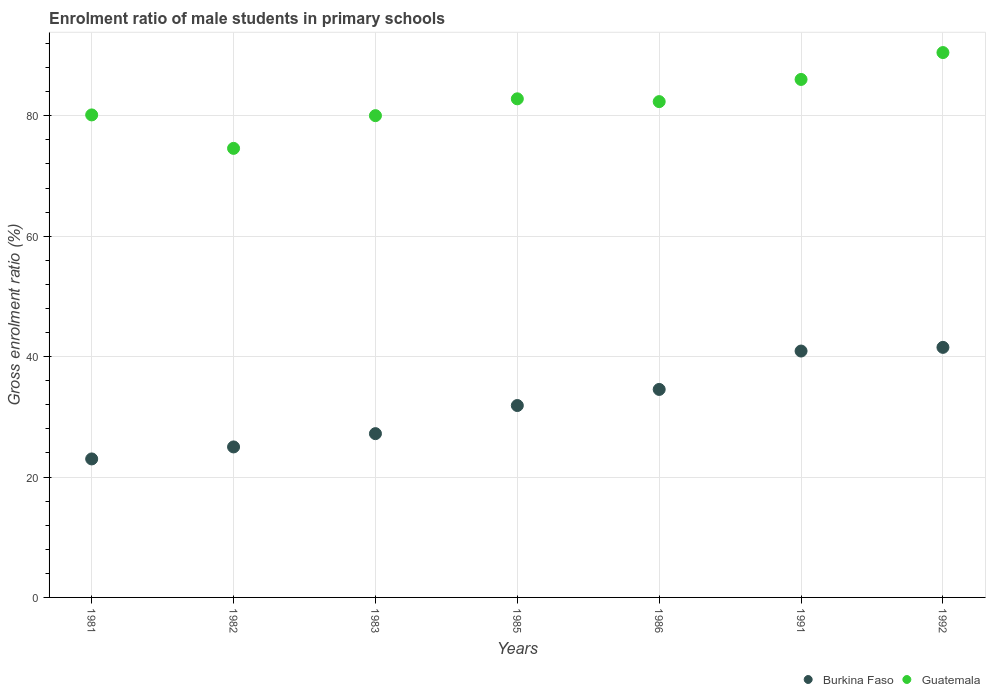How many different coloured dotlines are there?
Make the answer very short. 2. Is the number of dotlines equal to the number of legend labels?
Your answer should be compact. Yes. What is the enrolment ratio of male students in primary schools in Guatemala in 1991?
Offer a very short reply. 86.04. Across all years, what is the maximum enrolment ratio of male students in primary schools in Guatemala?
Give a very brief answer. 90.5. Across all years, what is the minimum enrolment ratio of male students in primary schools in Burkina Faso?
Offer a terse response. 23. What is the total enrolment ratio of male students in primary schools in Burkina Faso in the graph?
Make the answer very short. 224.08. What is the difference between the enrolment ratio of male students in primary schools in Burkina Faso in 1985 and that in 1986?
Keep it short and to the point. -2.67. What is the difference between the enrolment ratio of male students in primary schools in Burkina Faso in 1985 and the enrolment ratio of male students in primary schools in Guatemala in 1981?
Keep it short and to the point. -48.27. What is the average enrolment ratio of male students in primary schools in Guatemala per year?
Give a very brief answer. 82.35. In the year 1992, what is the difference between the enrolment ratio of male students in primary schools in Burkina Faso and enrolment ratio of male students in primary schools in Guatemala?
Your answer should be very brief. -48.96. In how many years, is the enrolment ratio of male students in primary schools in Burkina Faso greater than 20 %?
Offer a very short reply. 7. What is the ratio of the enrolment ratio of male students in primary schools in Burkina Faso in 1985 to that in 1986?
Provide a short and direct response. 0.92. Is the enrolment ratio of male students in primary schools in Guatemala in 1981 less than that in 1985?
Your answer should be compact. Yes. Is the difference between the enrolment ratio of male students in primary schools in Burkina Faso in 1982 and 1985 greater than the difference between the enrolment ratio of male students in primary schools in Guatemala in 1982 and 1985?
Offer a very short reply. Yes. What is the difference between the highest and the second highest enrolment ratio of male students in primary schools in Guatemala?
Your answer should be compact. 4.46. What is the difference between the highest and the lowest enrolment ratio of male students in primary schools in Guatemala?
Your response must be concise. 15.91. Is the enrolment ratio of male students in primary schools in Burkina Faso strictly greater than the enrolment ratio of male students in primary schools in Guatemala over the years?
Offer a terse response. No. Is the enrolment ratio of male students in primary schools in Guatemala strictly less than the enrolment ratio of male students in primary schools in Burkina Faso over the years?
Make the answer very short. No. What is the difference between two consecutive major ticks on the Y-axis?
Provide a succinct answer. 20. Are the values on the major ticks of Y-axis written in scientific E-notation?
Your answer should be compact. No. Does the graph contain any zero values?
Offer a terse response. No. Does the graph contain grids?
Provide a short and direct response. Yes. Where does the legend appear in the graph?
Ensure brevity in your answer.  Bottom right. What is the title of the graph?
Ensure brevity in your answer.  Enrolment ratio of male students in primary schools. What is the Gross enrolment ratio (%) of Burkina Faso in 1981?
Give a very brief answer. 23. What is the Gross enrolment ratio (%) of Guatemala in 1981?
Provide a succinct answer. 80.14. What is the Gross enrolment ratio (%) in Burkina Faso in 1982?
Ensure brevity in your answer.  25. What is the Gross enrolment ratio (%) in Guatemala in 1982?
Your response must be concise. 74.59. What is the Gross enrolment ratio (%) of Burkina Faso in 1983?
Offer a very short reply. 27.2. What is the Gross enrolment ratio (%) in Guatemala in 1983?
Your answer should be compact. 80.02. What is the Gross enrolment ratio (%) of Burkina Faso in 1985?
Make the answer very short. 31.87. What is the Gross enrolment ratio (%) of Guatemala in 1985?
Offer a terse response. 82.82. What is the Gross enrolment ratio (%) of Burkina Faso in 1986?
Provide a succinct answer. 34.55. What is the Gross enrolment ratio (%) of Guatemala in 1986?
Offer a terse response. 82.35. What is the Gross enrolment ratio (%) in Burkina Faso in 1991?
Your answer should be very brief. 40.92. What is the Gross enrolment ratio (%) in Guatemala in 1991?
Offer a terse response. 86.04. What is the Gross enrolment ratio (%) of Burkina Faso in 1992?
Keep it short and to the point. 41.53. What is the Gross enrolment ratio (%) of Guatemala in 1992?
Your response must be concise. 90.5. Across all years, what is the maximum Gross enrolment ratio (%) in Burkina Faso?
Offer a terse response. 41.53. Across all years, what is the maximum Gross enrolment ratio (%) of Guatemala?
Provide a succinct answer. 90.5. Across all years, what is the minimum Gross enrolment ratio (%) in Burkina Faso?
Your answer should be very brief. 23. Across all years, what is the minimum Gross enrolment ratio (%) of Guatemala?
Offer a terse response. 74.59. What is the total Gross enrolment ratio (%) of Burkina Faso in the graph?
Your response must be concise. 224.08. What is the total Gross enrolment ratio (%) in Guatemala in the graph?
Keep it short and to the point. 576.45. What is the difference between the Gross enrolment ratio (%) of Burkina Faso in 1981 and that in 1982?
Offer a terse response. -1.99. What is the difference between the Gross enrolment ratio (%) in Guatemala in 1981 and that in 1982?
Provide a short and direct response. 5.56. What is the difference between the Gross enrolment ratio (%) in Burkina Faso in 1981 and that in 1983?
Make the answer very short. -4.2. What is the difference between the Gross enrolment ratio (%) of Guatemala in 1981 and that in 1983?
Make the answer very short. 0.12. What is the difference between the Gross enrolment ratio (%) in Burkina Faso in 1981 and that in 1985?
Ensure brevity in your answer.  -8.87. What is the difference between the Gross enrolment ratio (%) in Guatemala in 1981 and that in 1985?
Offer a terse response. -2.67. What is the difference between the Gross enrolment ratio (%) of Burkina Faso in 1981 and that in 1986?
Give a very brief answer. -11.54. What is the difference between the Gross enrolment ratio (%) in Guatemala in 1981 and that in 1986?
Offer a very short reply. -2.21. What is the difference between the Gross enrolment ratio (%) in Burkina Faso in 1981 and that in 1991?
Offer a terse response. -17.92. What is the difference between the Gross enrolment ratio (%) of Guatemala in 1981 and that in 1991?
Your answer should be compact. -5.89. What is the difference between the Gross enrolment ratio (%) of Burkina Faso in 1981 and that in 1992?
Your answer should be very brief. -18.53. What is the difference between the Gross enrolment ratio (%) of Guatemala in 1981 and that in 1992?
Make the answer very short. -10.36. What is the difference between the Gross enrolment ratio (%) in Burkina Faso in 1982 and that in 1983?
Offer a very short reply. -2.21. What is the difference between the Gross enrolment ratio (%) of Guatemala in 1982 and that in 1983?
Offer a terse response. -5.43. What is the difference between the Gross enrolment ratio (%) in Burkina Faso in 1982 and that in 1985?
Offer a very short reply. -6.88. What is the difference between the Gross enrolment ratio (%) of Guatemala in 1982 and that in 1985?
Your response must be concise. -8.23. What is the difference between the Gross enrolment ratio (%) in Burkina Faso in 1982 and that in 1986?
Your answer should be very brief. -9.55. What is the difference between the Gross enrolment ratio (%) of Guatemala in 1982 and that in 1986?
Your answer should be compact. -7.77. What is the difference between the Gross enrolment ratio (%) in Burkina Faso in 1982 and that in 1991?
Your answer should be compact. -15.93. What is the difference between the Gross enrolment ratio (%) of Guatemala in 1982 and that in 1991?
Keep it short and to the point. -11.45. What is the difference between the Gross enrolment ratio (%) of Burkina Faso in 1982 and that in 1992?
Offer a very short reply. -16.54. What is the difference between the Gross enrolment ratio (%) in Guatemala in 1982 and that in 1992?
Your response must be concise. -15.91. What is the difference between the Gross enrolment ratio (%) of Burkina Faso in 1983 and that in 1985?
Offer a terse response. -4.67. What is the difference between the Gross enrolment ratio (%) in Guatemala in 1983 and that in 1985?
Your response must be concise. -2.8. What is the difference between the Gross enrolment ratio (%) of Burkina Faso in 1983 and that in 1986?
Provide a succinct answer. -7.34. What is the difference between the Gross enrolment ratio (%) in Guatemala in 1983 and that in 1986?
Your answer should be very brief. -2.33. What is the difference between the Gross enrolment ratio (%) of Burkina Faso in 1983 and that in 1991?
Give a very brief answer. -13.72. What is the difference between the Gross enrolment ratio (%) of Guatemala in 1983 and that in 1991?
Give a very brief answer. -6.01. What is the difference between the Gross enrolment ratio (%) in Burkina Faso in 1983 and that in 1992?
Provide a short and direct response. -14.33. What is the difference between the Gross enrolment ratio (%) of Guatemala in 1983 and that in 1992?
Your answer should be very brief. -10.48. What is the difference between the Gross enrolment ratio (%) of Burkina Faso in 1985 and that in 1986?
Offer a very short reply. -2.67. What is the difference between the Gross enrolment ratio (%) of Guatemala in 1985 and that in 1986?
Ensure brevity in your answer.  0.46. What is the difference between the Gross enrolment ratio (%) of Burkina Faso in 1985 and that in 1991?
Give a very brief answer. -9.05. What is the difference between the Gross enrolment ratio (%) in Guatemala in 1985 and that in 1991?
Your response must be concise. -3.22. What is the difference between the Gross enrolment ratio (%) in Burkina Faso in 1985 and that in 1992?
Your response must be concise. -9.66. What is the difference between the Gross enrolment ratio (%) of Guatemala in 1985 and that in 1992?
Provide a short and direct response. -7.68. What is the difference between the Gross enrolment ratio (%) in Burkina Faso in 1986 and that in 1991?
Make the answer very short. -6.38. What is the difference between the Gross enrolment ratio (%) of Guatemala in 1986 and that in 1991?
Offer a very short reply. -3.68. What is the difference between the Gross enrolment ratio (%) in Burkina Faso in 1986 and that in 1992?
Ensure brevity in your answer.  -6.99. What is the difference between the Gross enrolment ratio (%) in Guatemala in 1986 and that in 1992?
Keep it short and to the point. -8.15. What is the difference between the Gross enrolment ratio (%) in Burkina Faso in 1991 and that in 1992?
Your answer should be compact. -0.61. What is the difference between the Gross enrolment ratio (%) in Guatemala in 1991 and that in 1992?
Provide a short and direct response. -4.46. What is the difference between the Gross enrolment ratio (%) in Burkina Faso in 1981 and the Gross enrolment ratio (%) in Guatemala in 1982?
Offer a very short reply. -51.58. What is the difference between the Gross enrolment ratio (%) of Burkina Faso in 1981 and the Gross enrolment ratio (%) of Guatemala in 1983?
Provide a short and direct response. -57.02. What is the difference between the Gross enrolment ratio (%) of Burkina Faso in 1981 and the Gross enrolment ratio (%) of Guatemala in 1985?
Your answer should be compact. -59.81. What is the difference between the Gross enrolment ratio (%) in Burkina Faso in 1981 and the Gross enrolment ratio (%) in Guatemala in 1986?
Your answer should be very brief. -59.35. What is the difference between the Gross enrolment ratio (%) in Burkina Faso in 1981 and the Gross enrolment ratio (%) in Guatemala in 1991?
Your answer should be compact. -63.03. What is the difference between the Gross enrolment ratio (%) of Burkina Faso in 1981 and the Gross enrolment ratio (%) of Guatemala in 1992?
Your answer should be compact. -67.5. What is the difference between the Gross enrolment ratio (%) of Burkina Faso in 1982 and the Gross enrolment ratio (%) of Guatemala in 1983?
Provide a short and direct response. -55.02. What is the difference between the Gross enrolment ratio (%) of Burkina Faso in 1982 and the Gross enrolment ratio (%) of Guatemala in 1985?
Keep it short and to the point. -57.82. What is the difference between the Gross enrolment ratio (%) of Burkina Faso in 1982 and the Gross enrolment ratio (%) of Guatemala in 1986?
Make the answer very short. -57.35. What is the difference between the Gross enrolment ratio (%) of Burkina Faso in 1982 and the Gross enrolment ratio (%) of Guatemala in 1991?
Your response must be concise. -61.04. What is the difference between the Gross enrolment ratio (%) in Burkina Faso in 1982 and the Gross enrolment ratio (%) in Guatemala in 1992?
Your answer should be very brief. -65.5. What is the difference between the Gross enrolment ratio (%) of Burkina Faso in 1983 and the Gross enrolment ratio (%) of Guatemala in 1985?
Ensure brevity in your answer.  -55.61. What is the difference between the Gross enrolment ratio (%) in Burkina Faso in 1983 and the Gross enrolment ratio (%) in Guatemala in 1986?
Provide a short and direct response. -55.15. What is the difference between the Gross enrolment ratio (%) of Burkina Faso in 1983 and the Gross enrolment ratio (%) of Guatemala in 1991?
Offer a very short reply. -58.83. What is the difference between the Gross enrolment ratio (%) of Burkina Faso in 1983 and the Gross enrolment ratio (%) of Guatemala in 1992?
Your answer should be compact. -63.3. What is the difference between the Gross enrolment ratio (%) in Burkina Faso in 1985 and the Gross enrolment ratio (%) in Guatemala in 1986?
Provide a succinct answer. -50.48. What is the difference between the Gross enrolment ratio (%) in Burkina Faso in 1985 and the Gross enrolment ratio (%) in Guatemala in 1991?
Your response must be concise. -54.16. What is the difference between the Gross enrolment ratio (%) in Burkina Faso in 1985 and the Gross enrolment ratio (%) in Guatemala in 1992?
Provide a short and direct response. -58.62. What is the difference between the Gross enrolment ratio (%) of Burkina Faso in 1986 and the Gross enrolment ratio (%) of Guatemala in 1991?
Provide a succinct answer. -51.49. What is the difference between the Gross enrolment ratio (%) of Burkina Faso in 1986 and the Gross enrolment ratio (%) of Guatemala in 1992?
Ensure brevity in your answer.  -55.95. What is the difference between the Gross enrolment ratio (%) of Burkina Faso in 1991 and the Gross enrolment ratio (%) of Guatemala in 1992?
Your answer should be compact. -49.58. What is the average Gross enrolment ratio (%) of Burkina Faso per year?
Keep it short and to the point. 32.01. What is the average Gross enrolment ratio (%) of Guatemala per year?
Ensure brevity in your answer.  82.35. In the year 1981, what is the difference between the Gross enrolment ratio (%) in Burkina Faso and Gross enrolment ratio (%) in Guatemala?
Your answer should be compact. -57.14. In the year 1982, what is the difference between the Gross enrolment ratio (%) of Burkina Faso and Gross enrolment ratio (%) of Guatemala?
Your answer should be compact. -49.59. In the year 1983, what is the difference between the Gross enrolment ratio (%) in Burkina Faso and Gross enrolment ratio (%) in Guatemala?
Provide a succinct answer. -52.82. In the year 1985, what is the difference between the Gross enrolment ratio (%) of Burkina Faso and Gross enrolment ratio (%) of Guatemala?
Keep it short and to the point. -50.94. In the year 1986, what is the difference between the Gross enrolment ratio (%) of Burkina Faso and Gross enrolment ratio (%) of Guatemala?
Keep it short and to the point. -47.8. In the year 1991, what is the difference between the Gross enrolment ratio (%) in Burkina Faso and Gross enrolment ratio (%) in Guatemala?
Ensure brevity in your answer.  -45.11. In the year 1992, what is the difference between the Gross enrolment ratio (%) in Burkina Faso and Gross enrolment ratio (%) in Guatemala?
Your answer should be very brief. -48.96. What is the ratio of the Gross enrolment ratio (%) in Burkina Faso in 1981 to that in 1982?
Offer a very short reply. 0.92. What is the ratio of the Gross enrolment ratio (%) in Guatemala in 1981 to that in 1982?
Make the answer very short. 1.07. What is the ratio of the Gross enrolment ratio (%) in Burkina Faso in 1981 to that in 1983?
Provide a succinct answer. 0.85. What is the ratio of the Gross enrolment ratio (%) in Burkina Faso in 1981 to that in 1985?
Give a very brief answer. 0.72. What is the ratio of the Gross enrolment ratio (%) of Burkina Faso in 1981 to that in 1986?
Your answer should be compact. 0.67. What is the ratio of the Gross enrolment ratio (%) in Guatemala in 1981 to that in 1986?
Provide a succinct answer. 0.97. What is the ratio of the Gross enrolment ratio (%) of Burkina Faso in 1981 to that in 1991?
Offer a terse response. 0.56. What is the ratio of the Gross enrolment ratio (%) of Guatemala in 1981 to that in 1991?
Keep it short and to the point. 0.93. What is the ratio of the Gross enrolment ratio (%) in Burkina Faso in 1981 to that in 1992?
Keep it short and to the point. 0.55. What is the ratio of the Gross enrolment ratio (%) in Guatemala in 1981 to that in 1992?
Offer a very short reply. 0.89. What is the ratio of the Gross enrolment ratio (%) of Burkina Faso in 1982 to that in 1983?
Your answer should be very brief. 0.92. What is the ratio of the Gross enrolment ratio (%) in Guatemala in 1982 to that in 1983?
Offer a terse response. 0.93. What is the ratio of the Gross enrolment ratio (%) of Burkina Faso in 1982 to that in 1985?
Keep it short and to the point. 0.78. What is the ratio of the Gross enrolment ratio (%) of Guatemala in 1982 to that in 1985?
Your answer should be very brief. 0.9. What is the ratio of the Gross enrolment ratio (%) in Burkina Faso in 1982 to that in 1986?
Keep it short and to the point. 0.72. What is the ratio of the Gross enrolment ratio (%) of Guatemala in 1982 to that in 1986?
Offer a terse response. 0.91. What is the ratio of the Gross enrolment ratio (%) in Burkina Faso in 1982 to that in 1991?
Provide a succinct answer. 0.61. What is the ratio of the Gross enrolment ratio (%) of Guatemala in 1982 to that in 1991?
Provide a short and direct response. 0.87. What is the ratio of the Gross enrolment ratio (%) of Burkina Faso in 1982 to that in 1992?
Ensure brevity in your answer.  0.6. What is the ratio of the Gross enrolment ratio (%) in Guatemala in 1982 to that in 1992?
Ensure brevity in your answer.  0.82. What is the ratio of the Gross enrolment ratio (%) in Burkina Faso in 1983 to that in 1985?
Give a very brief answer. 0.85. What is the ratio of the Gross enrolment ratio (%) of Guatemala in 1983 to that in 1985?
Offer a very short reply. 0.97. What is the ratio of the Gross enrolment ratio (%) in Burkina Faso in 1983 to that in 1986?
Ensure brevity in your answer.  0.79. What is the ratio of the Gross enrolment ratio (%) of Guatemala in 1983 to that in 1986?
Offer a very short reply. 0.97. What is the ratio of the Gross enrolment ratio (%) in Burkina Faso in 1983 to that in 1991?
Your response must be concise. 0.66. What is the ratio of the Gross enrolment ratio (%) in Guatemala in 1983 to that in 1991?
Keep it short and to the point. 0.93. What is the ratio of the Gross enrolment ratio (%) of Burkina Faso in 1983 to that in 1992?
Provide a short and direct response. 0.66. What is the ratio of the Gross enrolment ratio (%) of Guatemala in 1983 to that in 1992?
Give a very brief answer. 0.88. What is the ratio of the Gross enrolment ratio (%) in Burkina Faso in 1985 to that in 1986?
Provide a short and direct response. 0.92. What is the ratio of the Gross enrolment ratio (%) of Guatemala in 1985 to that in 1986?
Offer a terse response. 1.01. What is the ratio of the Gross enrolment ratio (%) in Burkina Faso in 1985 to that in 1991?
Offer a very short reply. 0.78. What is the ratio of the Gross enrolment ratio (%) in Guatemala in 1985 to that in 1991?
Your answer should be very brief. 0.96. What is the ratio of the Gross enrolment ratio (%) in Burkina Faso in 1985 to that in 1992?
Your answer should be very brief. 0.77. What is the ratio of the Gross enrolment ratio (%) in Guatemala in 1985 to that in 1992?
Your response must be concise. 0.92. What is the ratio of the Gross enrolment ratio (%) in Burkina Faso in 1986 to that in 1991?
Provide a short and direct response. 0.84. What is the ratio of the Gross enrolment ratio (%) in Guatemala in 1986 to that in 1991?
Make the answer very short. 0.96. What is the ratio of the Gross enrolment ratio (%) of Burkina Faso in 1986 to that in 1992?
Offer a terse response. 0.83. What is the ratio of the Gross enrolment ratio (%) of Guatemala in 1986 to that in 1992?
Keep it short and to the point. 0.91. What is the ratio of the Gross enrolment ratio (%) in Burkina Faso in 1991 to that in 1992?
Make the answer very short. 0.99. What is the ratio of the Gross enrolment ratio (%) in Guatemala in 1991 to that in 1992?
Give a very brief answer. 0.95. What is the difference between the highest and the second highest Gross enrolment ratio (%) in Burkina Faso?
Provide a short and direct response. 0.61. What is the difference between the highest and the second highest Gross enrolment ratio (%) in Guatemala?
Your answer should be very brief. 4.46. What is the difference between the highest and the lowest Gross enrolment ratio (%) of Burkina Faso?
Keep it short and to the point. 18.53. What is the difference between the highest and the lowest Gross enrolment ratio (%) in Guatemala?
Give a very brief answer. 15.91. 